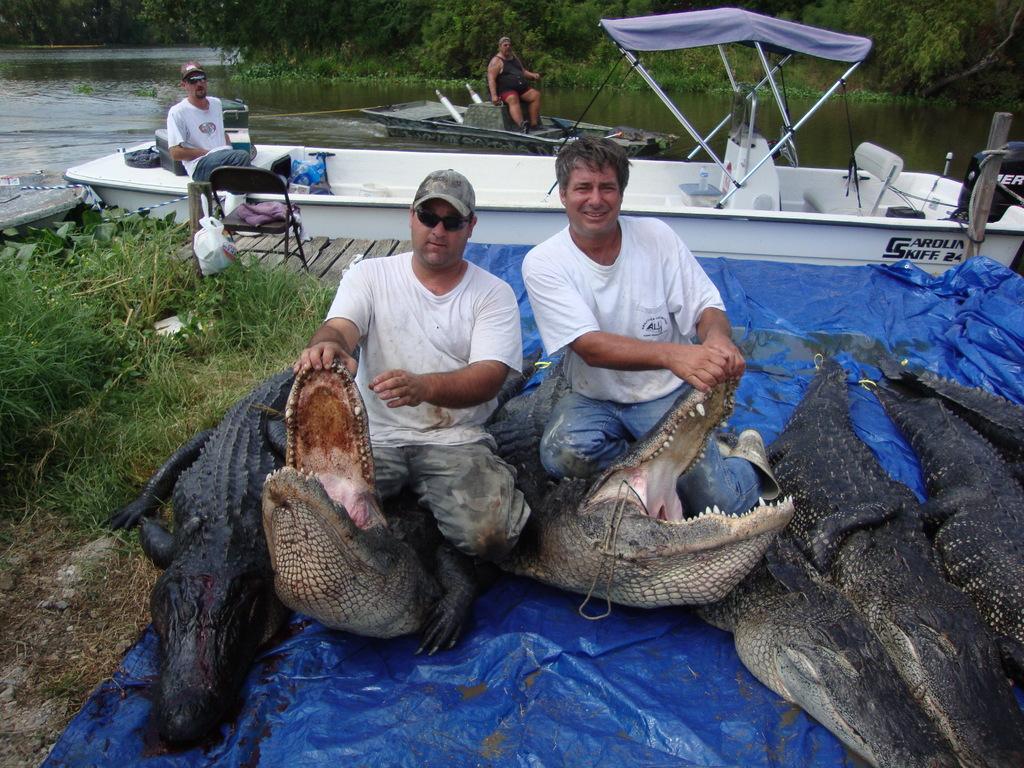Could you give a brief overview of what you see in this image? In this picture we can see two people are holding the mouth of the crocodiles. We can see some crocodiles on a blue sheet. Some grass is visible on the left side. There is a cloth on the chair. We can see a person on a boat in water. There is a bottle, box and other objects on this boat. There is another boat and a man is visible on this boat. Few trees are visible in the background. 